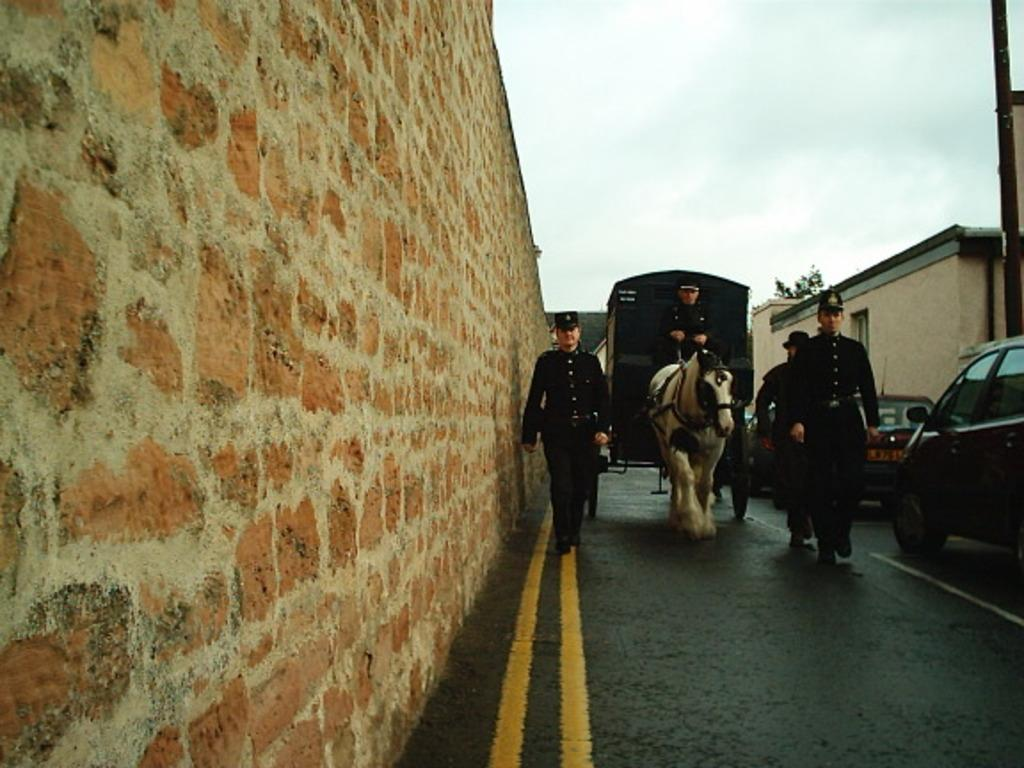What is the main subject of the image? There is a person riding a horse in the image. What is the person riding a horse doing? The person is in a cart. What else can be seen in the image besides the person riding a horse? There are three other persons on a path in the image, as well as vehicles, a house, and a wall. Where is the playground located in the image? There is no playground present in the image. What type of control does the person riding the horse have over the horse? The image does not provide information about the level of control the person has over the horse. 